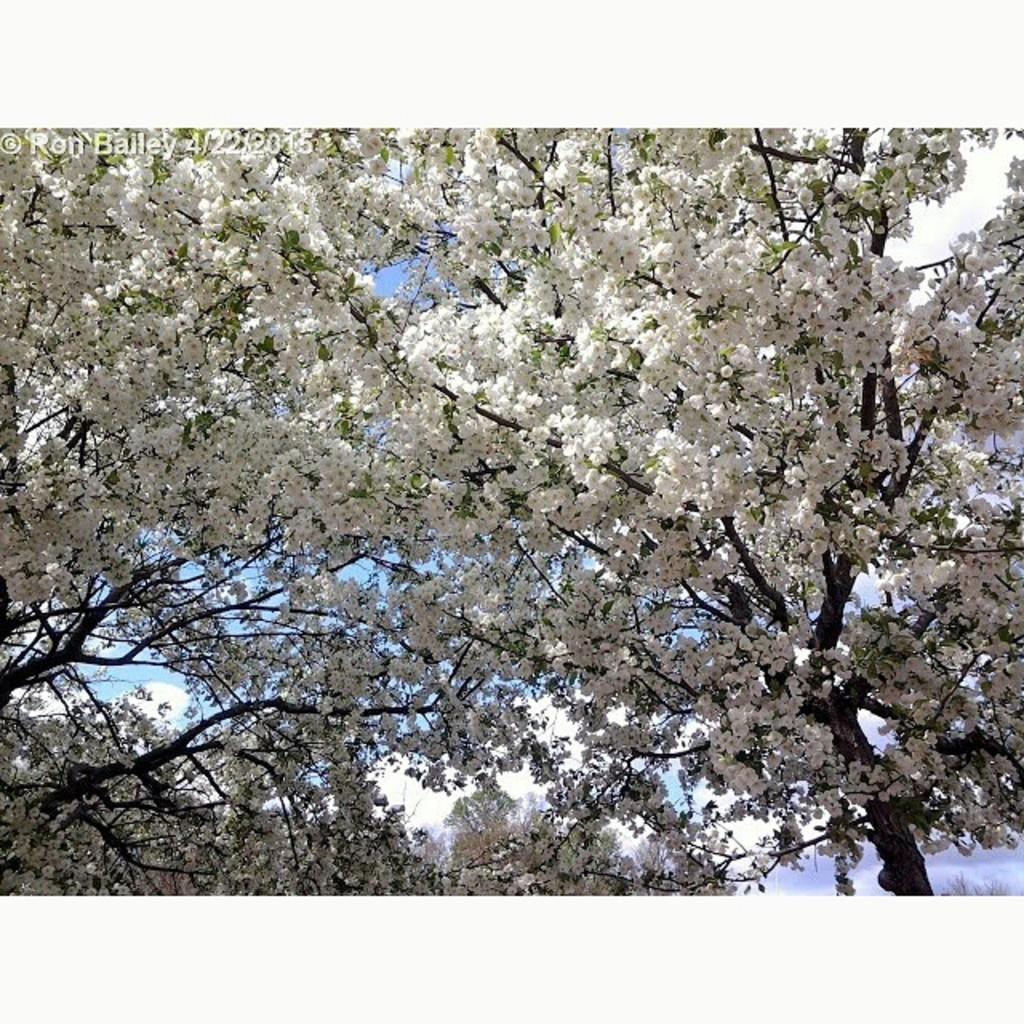What type of flora can be seen in the image? There are flowers in the image. What color are the flowers? The flowers are white in color. What can be seen in the background of the image? The sky is visible in the background of the image. What colors are present in the sky? The sky has both white and blue colors. Where is the nearest library to the location of the flowers in the image? There is no information about the location of the flowers or the nearest library in the image. 